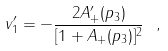Convert formula to latex. <formula><loc_0><loc_0><loc_500><loc_500>v ^ { \prime } _ { 1 } = - \frac { 2 A ^ { \prime } _ { + } ( p _ { 3 } ) } { [ 1 + A _ { + } ( p _ { 3 } ) ] ^ { 2 } } \ ,</formula> 